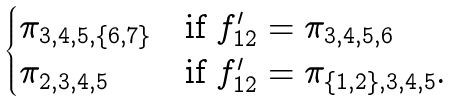<formula> <loc_0><loc_0><loc_500><loc_500>\begin{cases} \pi _ { 3 , 4 , 5 , \{ 6 , 7 \} } & \text {if $f^{\prime}_{12}=\pi_{3,4,5,6}$} \\ \pi _ { 2 , 3 , 4 , 5 } & \text {if $f^{\prime}_{12}=\pi_{\{1,2\},3,4,5}$.} \end{cases}</formula> 